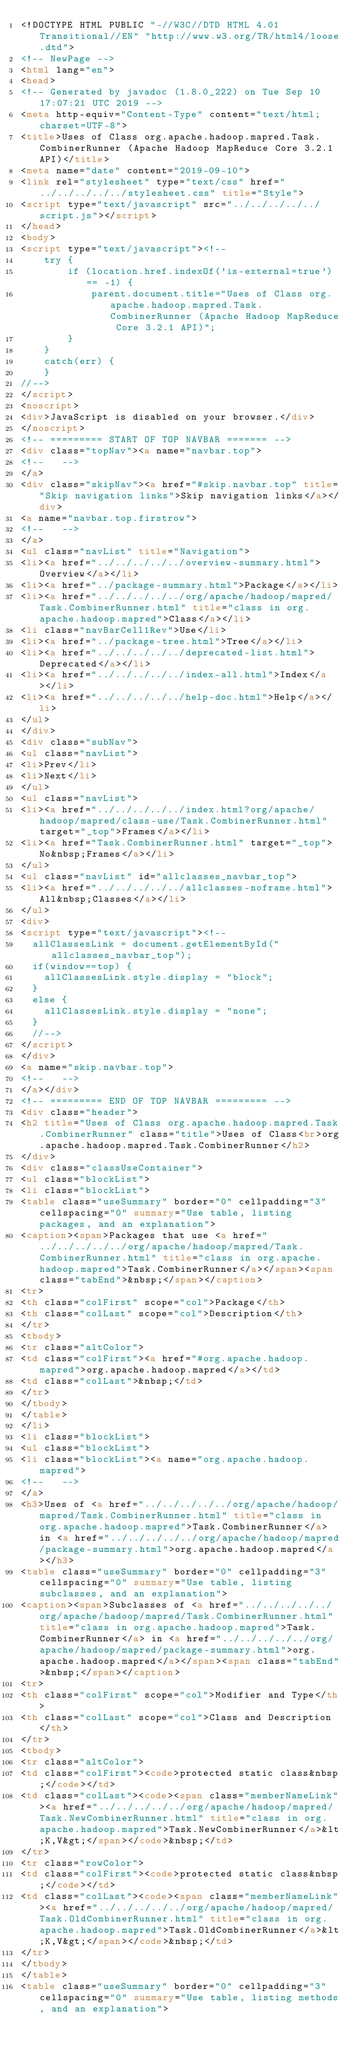Convert code to text. <code><loc_0><loc_0><loc_500><loc_500><_HTML_><!DOCTYPE HTML PUBLIC "-//W3C//DTD HTML 4.01 Transitional//EN" "http://www.w3.org/TR/html4/loose.dtd">
<!-- NewPage -->
<html lang="en">
<head>
<!-- Generated by javadoc (1.8.0_222) on Tue Sep 10 17:07:21 UTC 2019 -->
<meta http-equiv="Content-Type" content="text/html; charset=UTF-8">
<title>Uses of Class org.apache.hadoop.mapred.Task.CombinerRunner (Apache Hadoop MapReduce Core 3.2.1 API)</title>
<meta name="date" content="2019-09-10">
<link rel="stylesheet" type="text/css" href="../../../../../stylesheet.css" title="Style">
<script type="text/javascript" src="../../../../../script.js"></script>
</head>
<body>
<script type="text/javascript"><!--
    try {
        if (location.href.indexOf('is-external=true') == -1) {
            parent.document.title="Uses of Class org.apache.hadoop.mapred.Task.CombinerRunner (Apache Hadoop MapReduce Core 3.2.1 API)";
        }
    }
    catch(err) {
    }
//-->
</script>
<noscript>
<div>JavaScript is disabled on your browser.</div>
</noscript>
<!-- ========= START OF TOP NAVBAR ======= -->
<div class="topNav"><a name="navbar.top">
<!--   -->
</a>
<div class="skipNav"><a href="#skip.navbar.top" title="Skip navigation links">Skip navigation links</a></div>
<a name="navbar.top.firstrow">
<!--   -->
</a>
<ul class="navList" title="Navigation">
<li><a href="../../../../../overview-summary.html">Overview</a></li>
<li><a href="../package-summary.html">Package</a></li>
<li><a href="../../../../../org/apache/hadoop/mapred/Task.CombinerRunner.html" title="class in org.apache.hadoop.mapred">Class</a></li>
<li class="navBarCell1Rev">Use</li>
<li><a href="../package-tree.html">Tree</a></li>
<li><a href="../../../../../deprecated-list.html">Deprecated</a></li>
<li><a href="../../../../../index-all.html">Index</a></li>
<li><a href="../../../../../help-doc.html">Help</a></li>
</ul>
</div>
<div class="subNav">
<ul class="navList">
<li>Prev</li>
<li>Next</li>
</ul>
<ul class="navList">
<li><a href="../../../../../index.html?org/apache/hadoop/mapred/class-use/Task.CombinerRunner.html" target="_top">Frames</a></li>
<li><a href="Task.CombinerRunner.html" target="_top">No&nbsp;Frames</a></li>
</ul>
<ul class="navList" id="allclasses_navbar_top">
<li><a href="../../../../../allclasses-noframe.html">All&nbsp;Classes</a></li>
</ul>
<div>
<script type="text/javascript"><!--
  allClassesLink = document.getElementById("allclasses_navbar_top");
  if(window==top) {
    allClassesLink.style.display = "block";
  }
  else {
    allClassesLink.style.display = "none";
  }
  //-->
</script>
</div>
<a name="skip.navbar.top">
<!--   -->
</a></div>
<!-- ========= END OF TOP NAVBAR ========= -->
<div class="header">
<h2 title="Uses of Class org.apache.hadoop.mapred.Task.CombinerRunner" class="title">Uses of Class<br>org.apache.hadoop.mapred.Task.CombinerRunner</h2>
</div>
<div class="classUseContainer">
<ul class="blockList">
<li class="blockList">
<table class="useSummary" border="0" cellpadding="3" cellspacing="0" summary="Use table, listing packages, and an explanation">
<caption><span>Packages that use <a href="../../../../../org/apache/hadoop/mapred/Task.CombinerRunner.html" title="class in org.apache.hadoop.mapred">Task.CombinerRunner</a></span><span class="tabEnd">&nbsp;</span></caption>
<tr>
<th class="colFirst" scope="col">Package</th>
<th class="colLast" scope="col">Description</th>
</tr>
<tbody>
<tr class="altColor">
<td class="colFirst"><a href="#org.apache.hadoop.mapred">org.apache.hadoop.mapred</a></td>
<td class="colLast">&nbsp;</td>
</tr>
</tbody>
</table>
</li>
<li class="blockList">
<ul class="blockList">
<li class="blockList"><a name="org.apache.hadoop.mapred">
<!--   -->
</a>
<h3>Uses of <a href="../../../../../org/apache/hadoop/mapred/Task.CombinerRunner.html" title="class in org.apache.hadoop.mapred">Task.CombinerRunner</a> in <a href="../../../../../org/apache/hadoop/mapred/package-summary.html">org.apache.hadoop.mapred</a></h3>
<table class="useSummary" border="0" cellpadding="3" cellspacing="0" summary="Use table, listing subclasses, and an explanation">
<caption><span>Subclasses of <a href="../../../../../org/apache/hadoop/mapred/Task.CombinerRunner.html" title="class in org.apache.hadoop.mapred">Task.CombinerRunner</a> in <a href="../../../../../org/apache/hadoop/mapred/package-summary.html">org.apache.hadoop.mapred</a></span><span class="tabEnd">&nbsp;</span></caption>
<tr>
<th class="colFirst" scope="col">Modifier and Type</th>
<th class="colLast" scope="col">Class and Description</th>
</tr>
<tbody>
<tr class="altColor">
<td class="colFirst"><code>protected static class&nbsp;</code></td>
<td class="colLast"><code><span class="memberNameLink"><a href="../../../../../org/apache/hadoop/mapred/Task.NewCombinerRunner.html" title="class in org.apache.hadoop.mapred">Task.NewCombinerRunner</a>&lt;K,V&gt;</span></code>&nbsp;</td>
</tr>
<tr class="rowColor">
<td class="colFirst"><code>protected static class&nbsp;</code></td>
<td class="colLast"><code><span class="memberNameLink"><a href="../../../../../org/apache/hadoop/mapred/Task.OldCombinerRunner.html" title="class in org.apache.hadoop.mapred">Task.OldCombinerRunner</a>&lt;K,V&gt;</span></code>&nbsp;</td>
</tr>
</tbody>
</table>
<table class="useSummary" border="0" cellpadding="3" cellspacing="0" summary="Use table, listing methods, and an explanation"></code> 